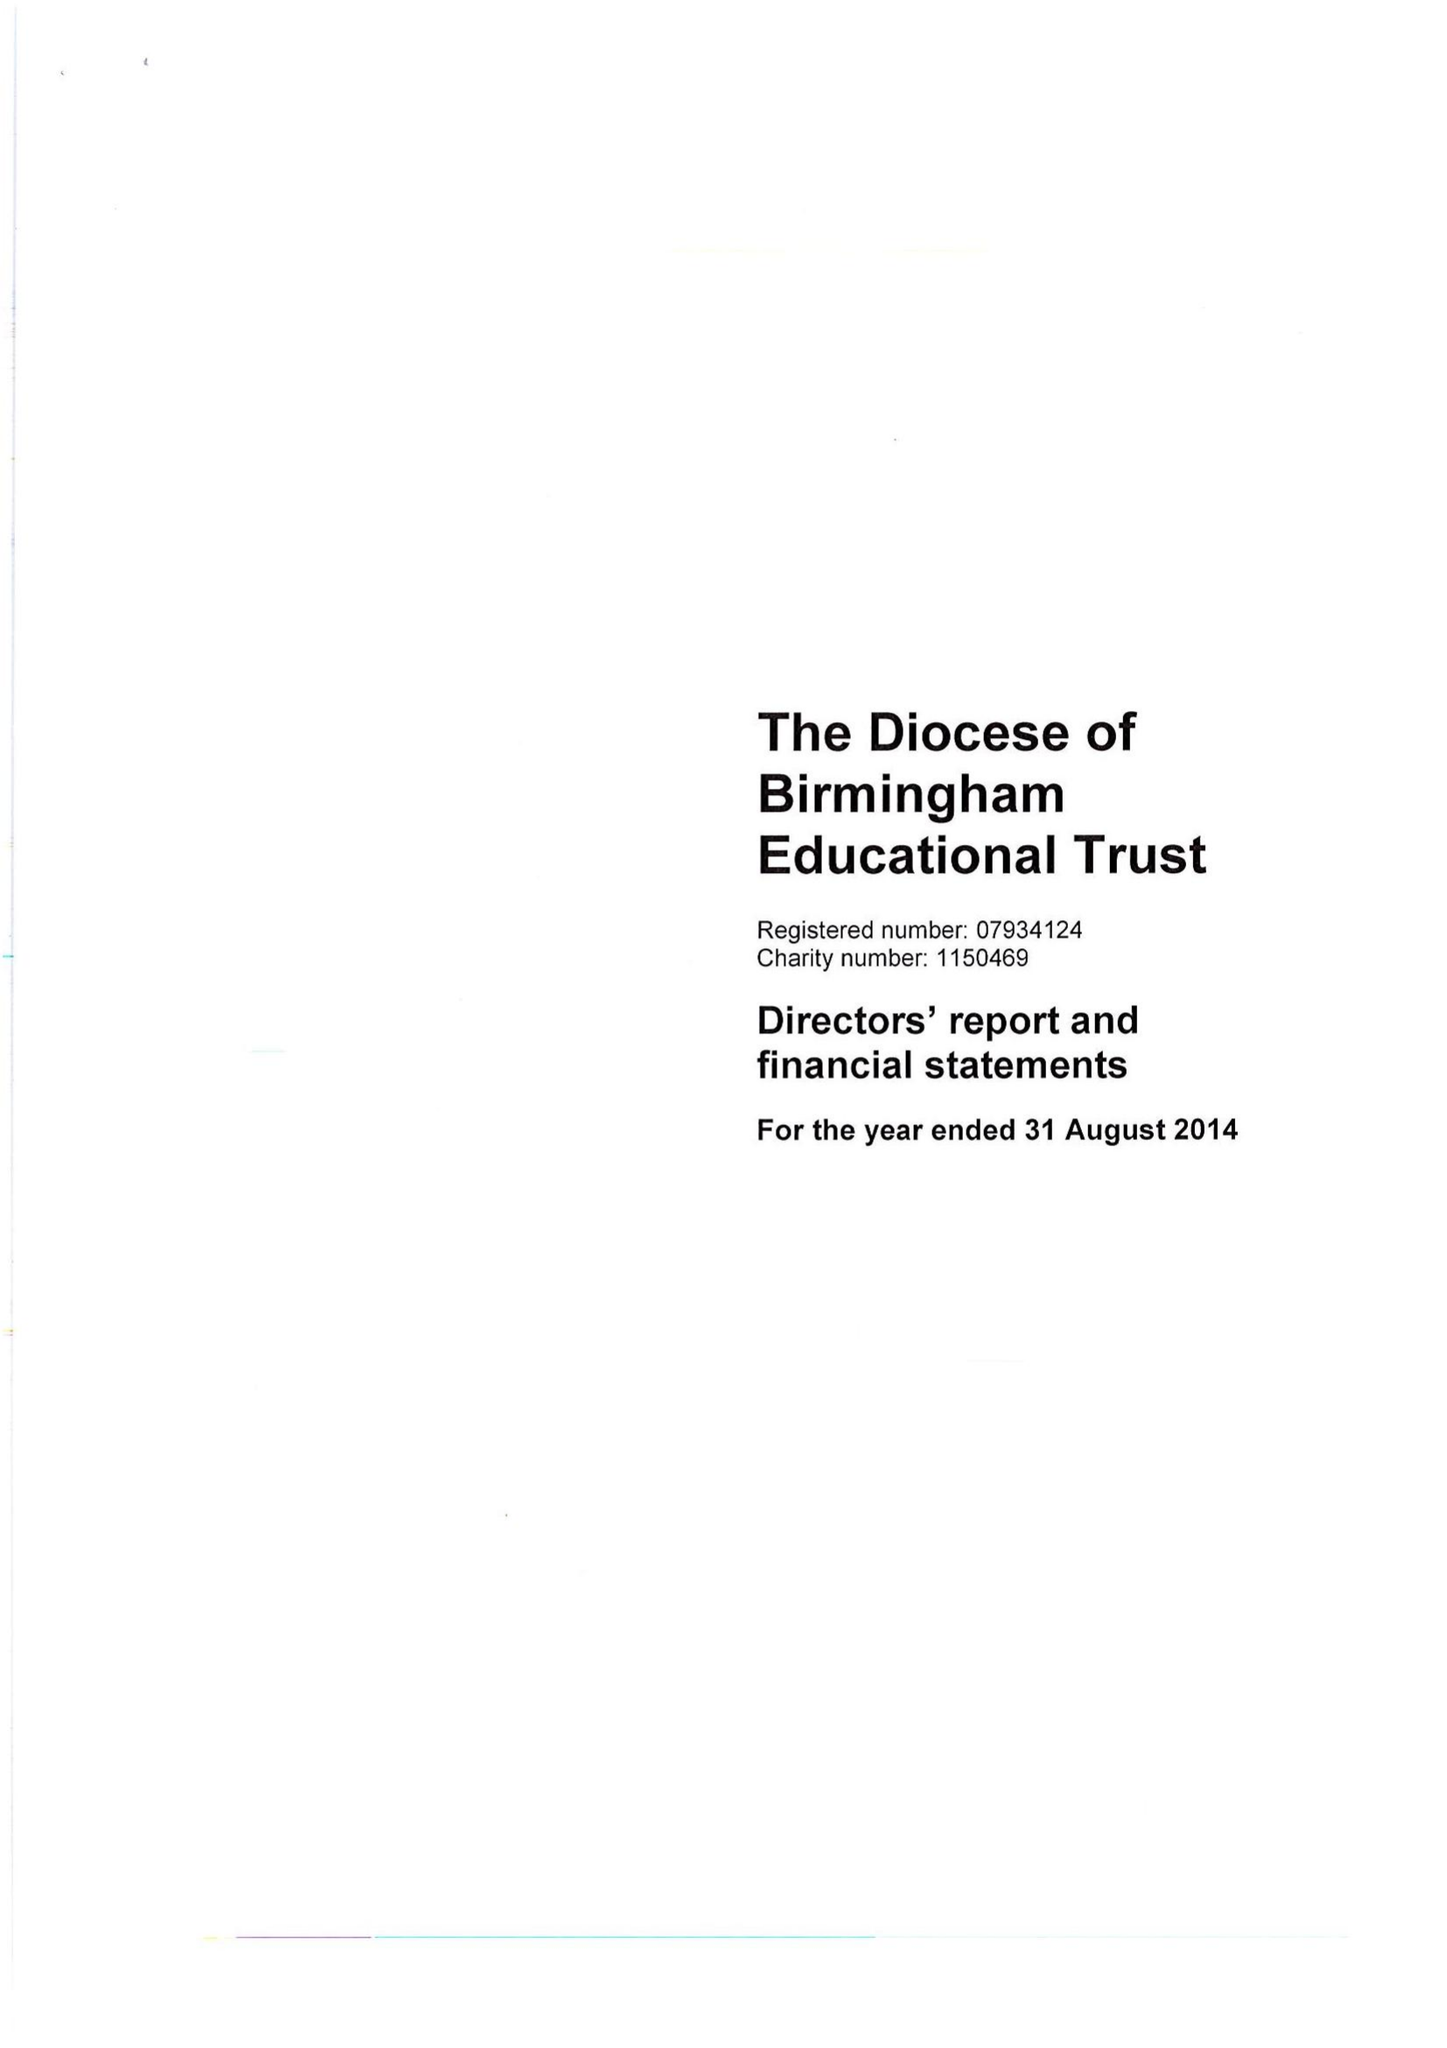What is the value for the address__post_town?
Answer the question using a single word or phrase. BIRMINGHAM 